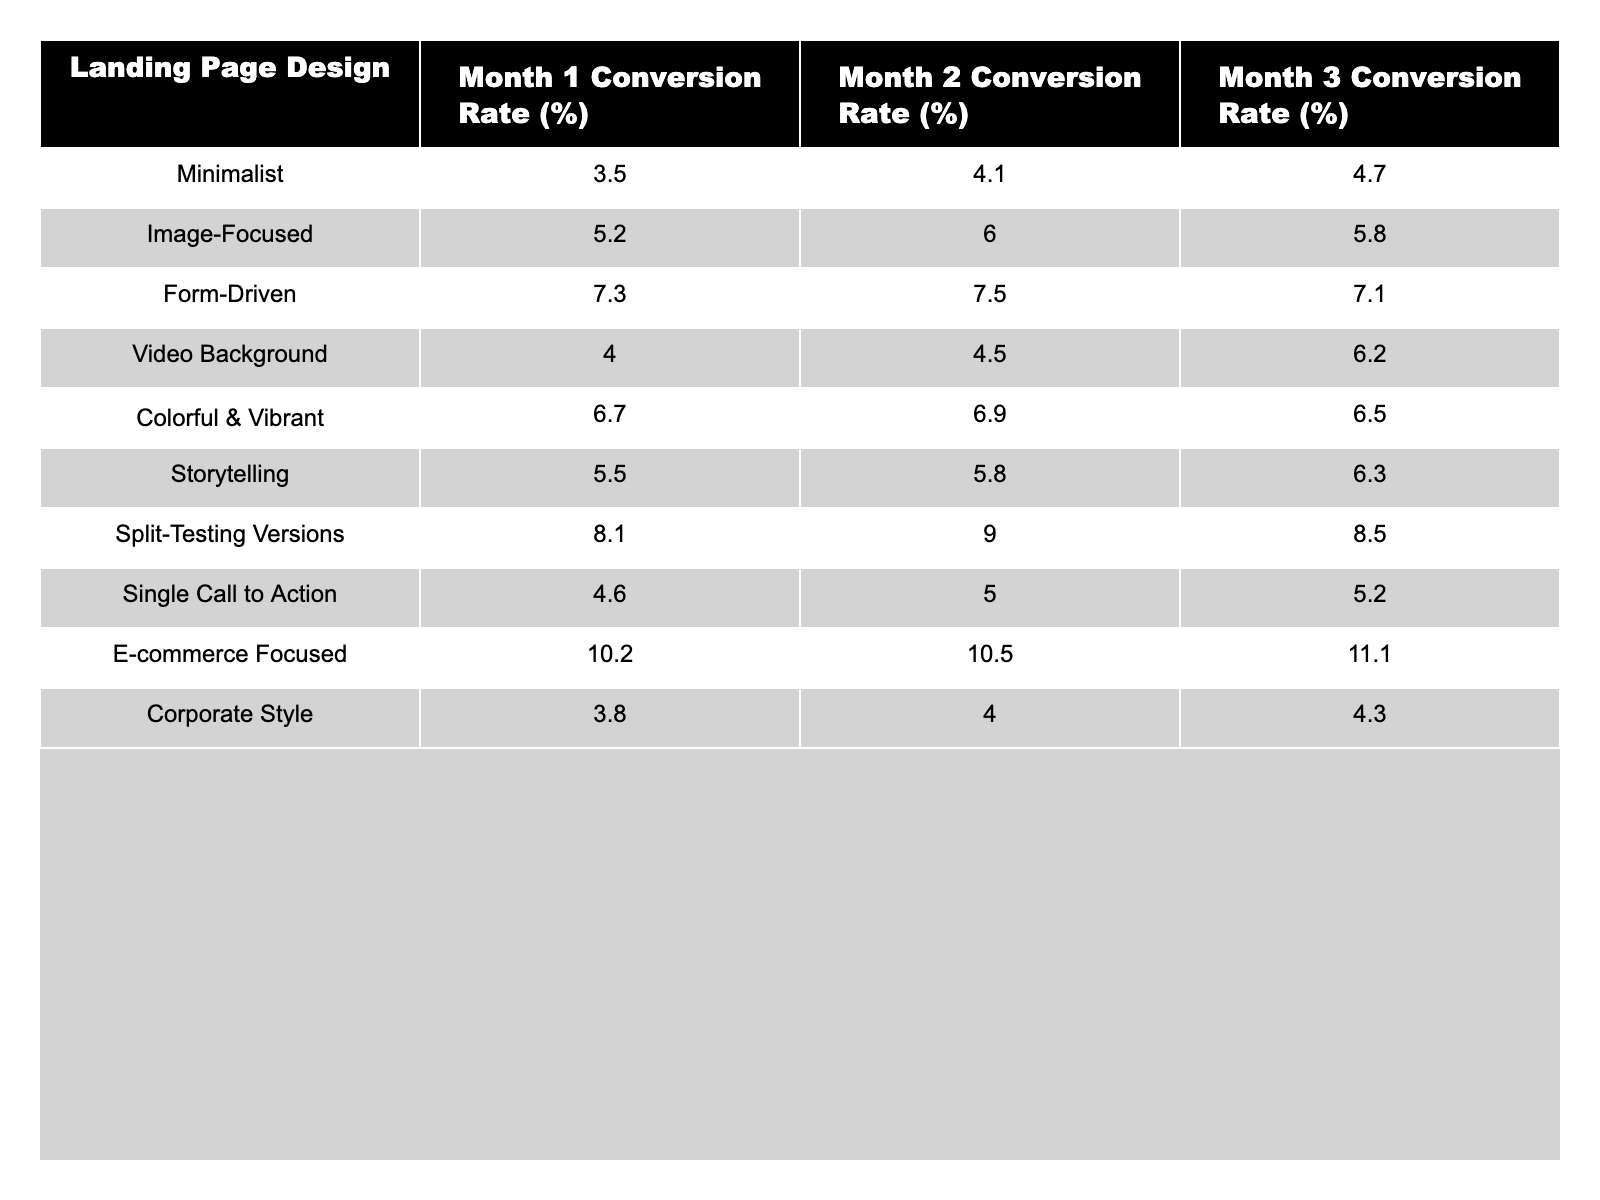What was the conversion rate for the E-commerce Focused design in Month 2? The E-commerce Focused design has a conversion rate of 10.5% listed under Month 2 in the table.
Answer: 10.5% What is the conversion rate increase from Month 1 to Month 3 for the Form-Driven design? The conversion rate in Month 1 is 7.3% and in Month 3 it is 7.1%. The difference is 7.1% - 7.3% = -0.2%, indicating a decrease.
Answer: -0.2% Which landing page design had the highest conversion rate in Month 3? The E-commerce Focused design has the highest conversion rate of 11.1% in Month 3, as compared to other designs listed.
Answer: E-commerce Focused Is the conversion rate for the Split-Testing Versions design consistently increasing over the three months? The conversion rates are 8.1% in Month 1, 9.0% in Month 2, and 8.5% in Month 3. Since Month 3 is lower than Month 2, it is not consistently increasing.
Answer: No What is the average conversion rate for the Colorful & Vibrant design over the three months? The conversion rates for Colorful & Vibrant are 6.7%, 6.9%, and 6.5%. The average is calculated as (6.7 + 6.9 + 6.5) / 3 = 6.7%.
Answer: 6.7% What was the change in conversion rate for Video Background from Month 1 to Month 2? The conversion rate in Month 1 is 4.0% and in Month 2 it is 4.5%. The change is 4.5% - 4.0% = 0.5%, indicating an increase.
Answer: 0.5% Did any landing page design have a conversion rate below 4% in any month? The lowest conversion rate listed is 3.5% for the Minimalist design in Month 1, which is below 4%.
Answer: Yes What is the total conversion rate for Image-Focused and E-commerce Focused designs in Month 3? The conversion rate for Image-Focused in Month 3 is 5.8% and for E-commerce Focused it is 11.1%. Summing them gives 5.8% + 11.1% = 16.9%.
Answer: 16.9% Which design had the largest positive difference between Month 1 and Month 2 in conversion rates? The Split-Testing Versions design shows an increase from 8.1% in Month 1 to 9.0% in Month 2, a difference of 0.9%. This is the largest positive difference among all designs.
Answer: Split-Testing Versions What proportion of landing page designs showed an increase from Month 1 to Month 3? Out of the 10 designs, 4 increased from Month 1 to Month 3 (Image-Focused, Video Background, Colorful & Vibrant, Split-Testing Versions). Thus, 4/10 = 0.4 or 40%.
Answer: 40% 